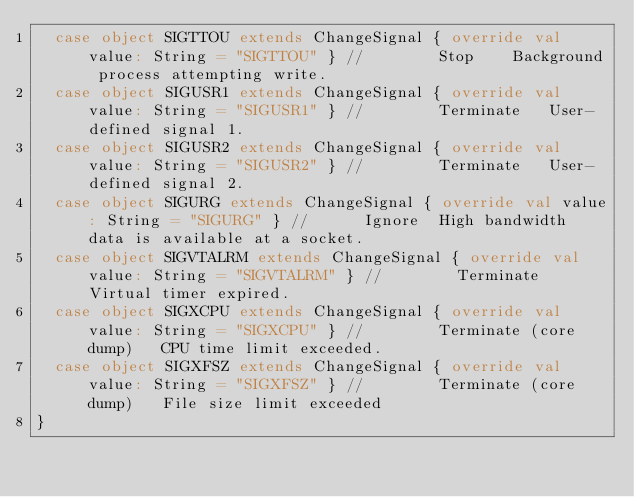<code> <loc_0><loc_0><loc_500><loc_500><_Scala_>  case object SIGTTOU extends ChangeSignal { override val value: String = "SIGTTOU" } //	 	Stop	Background process attempting write.
  case object SIGUSR1 extends ChangeSignal { override val value: String = "SIGUSR1" } //	 	Terminate	User-defined signal 1.
  case object SIGUSR2 extends ChangeSignal { override val value: String = "SIGUSR2" } //	 	Terminate	User-defined signal 2.
  case object SIGURG extends ChangeSignal { override val value: String = "SIGURG" } //	 	Ignore	High bandwidth data is available at a socket.
  case object SIGVTALRM extends ChangeSignal { override val value: String = "SIGVTALRM" } //	 	Terminate	Virtual timer expired.
  case object SIGXCPU extends ChangeSignal { override val value: String = "SIGXCPU" } //	 	Terminate (core dump)	CPU time limit exceeded.
  case object SIGXFSZ extends ChangeSignal { override val value: String = "SIGXFSZ" } //	 	Terminate (core dump)	File size limit exceeded
}</code> 